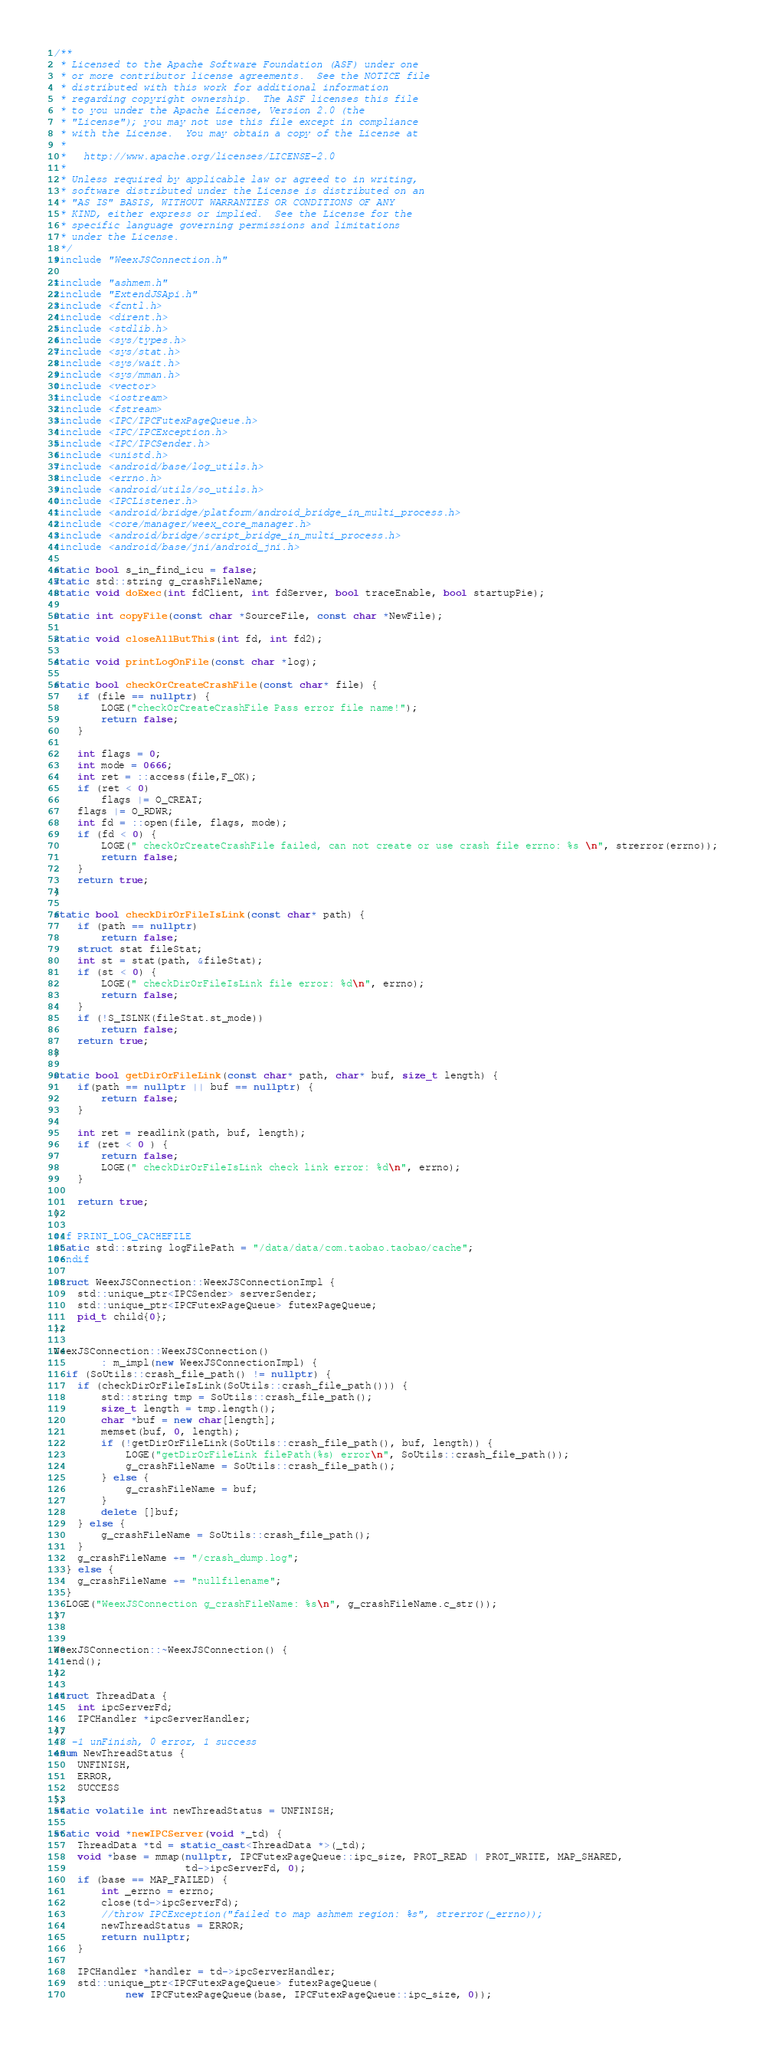<code> <loc_0><loc_0><loc_500><loc_500><_C++_>/**
 * Licensed to the Apache Software Foundation (ASF) under one
 * or more contributor license agreements.  See the NOTICE file
 * distributed with this work for additional information
 * regarding copyright ownership.  The ASF licenses this file
 * to you under the Apache License, Version 2.0 (the
 * "License"); you may not use this file except in compliance
 * with the License.  You may obtain a copy of the License at
 *
 *   http://www.apache.org/licenses/LICENSE-2.0
 *
 * Unless required by applicable law or agreed to in writing,
 * software distributed under the License is distributed on an
 * "AS IS" BASIS, WITHOUT WARRANTIES OR CONDITIONS OF ANY
 * KIND, either express or implied.  See the License for the
 * specific language governing permissions and limitations
 * under the License.
 */
#include "WeexJSConnection.h"

#include "ashmem.h"
#include "ExtendJSApi.h"
#include <fcntl.h>
#include <dirent.h>
#include <stdlib.h>
#include <sys/types.h>
#include <sys/stat.h>
#include <sys/wait.h>
#include <sys/mman.h>
#include <vector>
#include <iostream>
#include <fstream>
#include <IPC/IPCFutexPageQueue.h>
#include <IPC/IPCException.h>
#include <IPC/IPCSender.h>
#include <unistd.h>
#include <android/base/log_utils.h>
#include <errno.h>
#include <android/utils/so_utils.h>
#include <IPCListener.h>
#include <android/bridge/platform/android_bridge_in_multi_process.h>
#include <core/manager/weex_core_manager.h>
#include <android/bridge/script_bridge_in_multi_process.h>
#include <android/base/jni/android_jni.h>

static bool s_in_find_icu = false;
static std::string g_crashFileName;
static void doExec(int fdClient, int fdServer, bool traceEnable, bool startupPie);

static int copyFile(const char *SourceFile, const char *NewFile);

static void closeAllButThis(int fd, int fd2);

static void printLogOnFile(const char *log);

static bool checkOrCreateCrashFile(const char* file) {
    if (file == nullptr) {
        LOGE("checkOrCreateCrashFile Pass error file name!");
        return false;
    }

    int flags = 0;
    int mode = 0666;
    int ret = ::access(file,F_OK);
    if (ret < 0)
        flags |= O_CREAT;
    flags |= O_RDWR;
    int fd = ::open(file, flags, mode);
    if (fd < 0) {
        LOGE(" checkOrCreateCrashFile failed, can not create or use crash file errno: %s \n", strerror(errno));
        return false;
    }
    return true;
}

static bool checkDirOrFileIsLink(const char* path) {
    if (path == nullptr)
        return false;
    struct stat fileStat;
    int st = stat(path, &fileStat);
    if (st < 0) {
        LOGE(" checkDirOrFileIsLink file error: %d\n", errno);
        return false;
    }
    if (!S_ISLNK(fileStat.st_mode))
        return false;
    return true;
}

static bool getDirOrFileLink(const char* path, char* buf, size_t length) {
    if(path == nullptr || buf == nullptr) {
        return false;
    }

    int ret = readlink(path, buf, length);
    if (ret < 0 ) {
        return false;
        LOGE(" checkDirOrFileIsLink check link error: %d\n", errno);
    }

    return true;
}

#if PRINT_LOG_CACHEFILE
static std::string logFilePath = "/data/data/com.taobao.taobao/cache";
#endif

struct WeexJSConnection::WeexJSConnectionImpl {
    std::unique_ptr<IPCSender> serverSender;
    std::unique_ptr<IPCFutexPageQueue> futexPageQueue;
    pid_t child{0};
};

WeexJSConnection::WeexJSConnection()
        : m_impl(new WeexJSConnectionImpl) {
  if (SoUtils::crash_file_path() != nullptr) {
    if (checkDirOrFileIsLink(SoUtils::crash_file_path())) {
        std::string tmp = SoUtils::crash_file_path();
        size_t length = tmp.length();
        char *buf = new char[length];
        memset(buf, 0, length);
        if (!getDirOrFileLink(SoUtils::crash_file_path(), buf, length)) {
            LOGE("getDirOrFileLink filePath(%s) error\n", SoUtils::crash_file_path());
            g_crashFileName = SoUtils::crash_file_path();
        } else {
            g_crashFileName = buf;
        }
        delete []buf;
    } else {
        g_crashFileName = SoUtils::crash_file_path();
    }
    g_crashFileName += "/crash_dump.log";
  } else {
    g_crashFileName += "nullfilename";
  }
  LOGE("WeexJSConnection g_crashFileName: %s\n", g_crashFileName.c_str());
}


WeexJSConnection::~WeexJSConnection() {
  end();
}

struct ThreadData {
    int ipcServerFd;
    IPCHandler *ipcServerHandler;
};
// -1 unFinish, 0 error, 1 success
enum NewThreadStatus {
    UNFINISH,
    ERROR,
    SUCCESS
};
static volatile int newThreadStatus = UNFINISH;

static void *newIPCServer(void *_td) {
    ThreadData *td = static_cast<ThreadData *>(_td);
    void *base = mmap(nullptr, IPCFutexPageQueue::ipc_size, PROT_READ | PROT_WRITE, MAP_SHARED,
                      td->ipcServerFd, 0);
    if (base == MAP_FAILED) {
        int _errno = errno;
        close(td->ipcServerFd);
        //throw IPCException("failed to map ashmem region: %s", strerror(_errno));
        newThreadStatus = ERROR;
        return nullptr;
    }

    IPCHandler *handler = td->ipcServerHandler;
    std::unique_ptr<IPCFutexPageQueue> futexPageQueue(
            new IPCFutexPageQueue(base, IPCFutexPageQueue::ipc_size, 0));</code> 